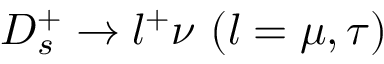Convert formula to latex. <formula><loc_0><loc_0><loc_500><loc_500>D _ { s } ^ { + } \to l ^ { + } \nu ( l = \mu , \tau )</formula> 